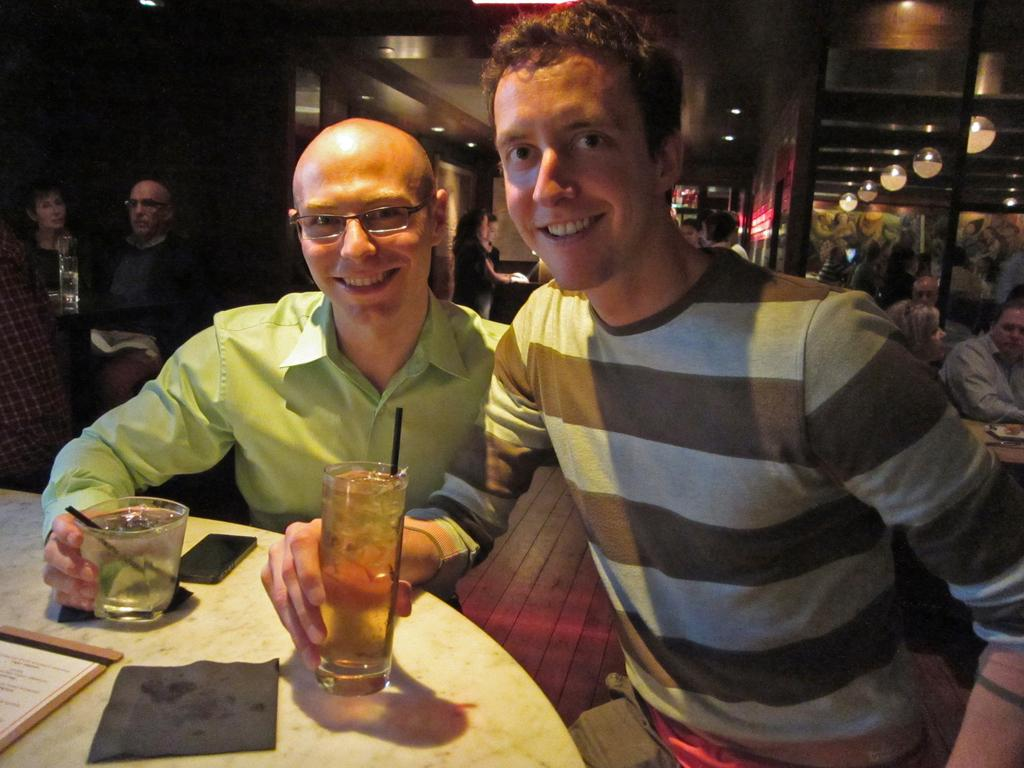How many people are sitting in the image? There are two persons sitting in the image. What are the two persons holding in their hands? The two persons are holding wine glasses. Where are the wine glasses placed? The wine glasses are placed on a table. Are there any other people visible in the image? Yes, there are additional persons in the left corner of the image. Is there a square-shaped river visible in the image? No, there is no river, square-shaped or otherwise, present in the image. 